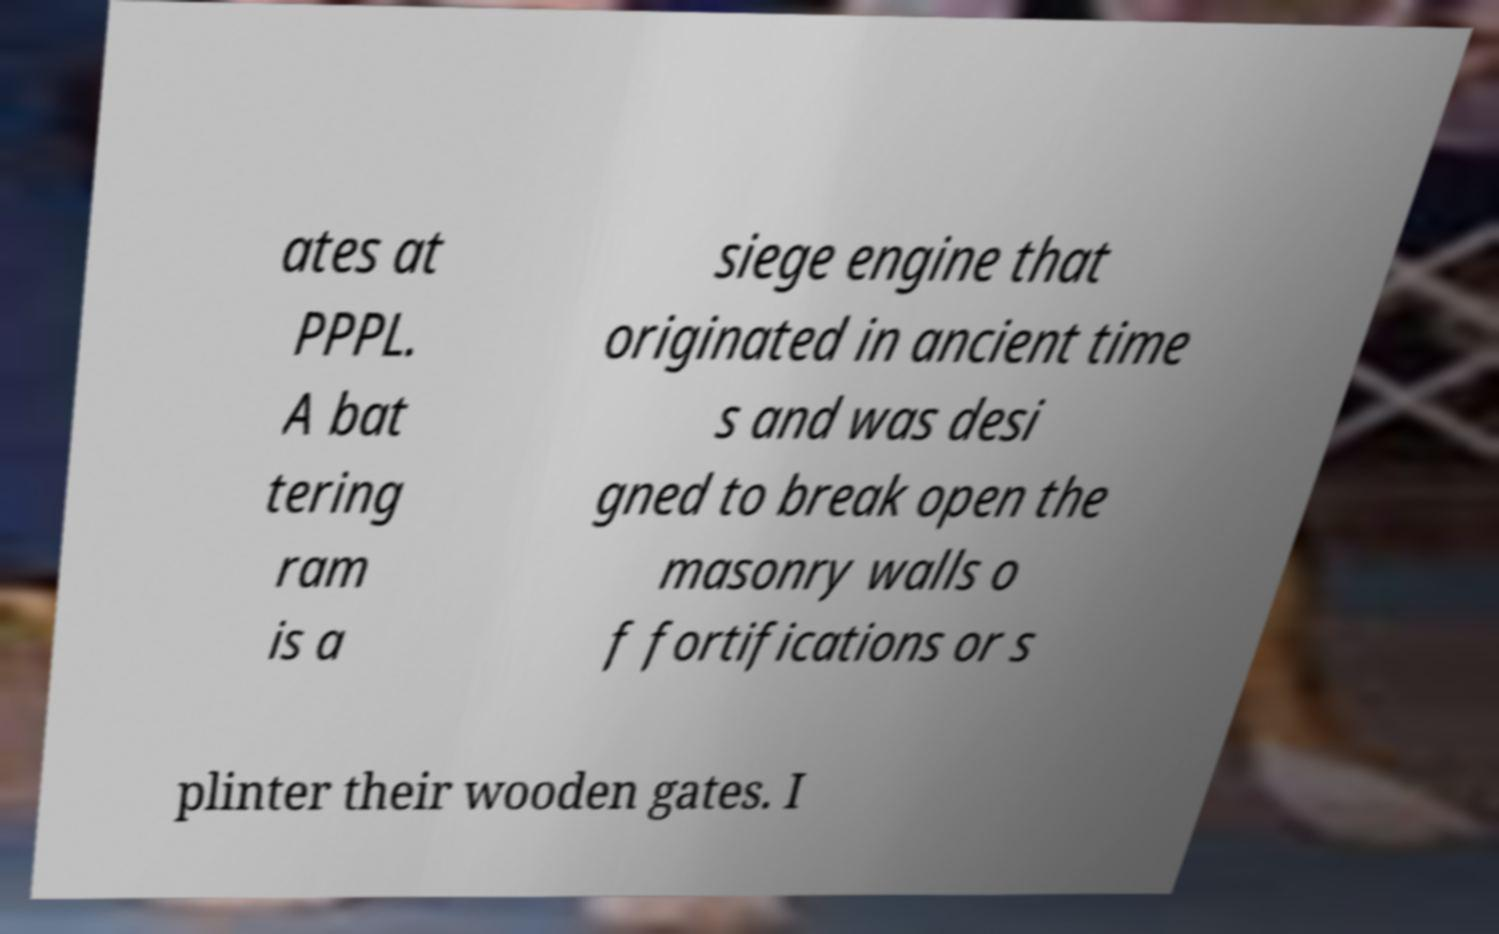Please read and relay the text visible in this image. What does it say? ates at PPPL. A bat tering ram is a siege engine that originated in ancient time s and was desi gned to break open the masonry walls o f fortifications or s plinter their wooden gates. I 